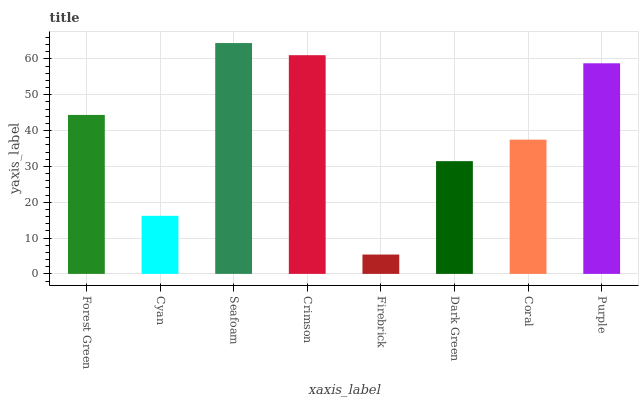Is Cyan the minimum?
Answer yes or no. No. Is Cyan the maximum?
Answer yes or no. No. Is Forest Green greater than Cyan?
Answer yes or no. Yes. Is Cyan less than Forest Green?
Answer yes or no. Yes. Is Cyan greater than Forest Green?
Answer yes or no. No. Is Forest Green less than Cyan?
Answer yes or no. No. Is Forest Green the high median?
Answer yes or no. Yes. Is Coral the low median?
Answer yes or no. Yes. Is Seafoam the high median?
Answer yes or no. No. Is Seafoam the low median?
Answer yes or no. No. 